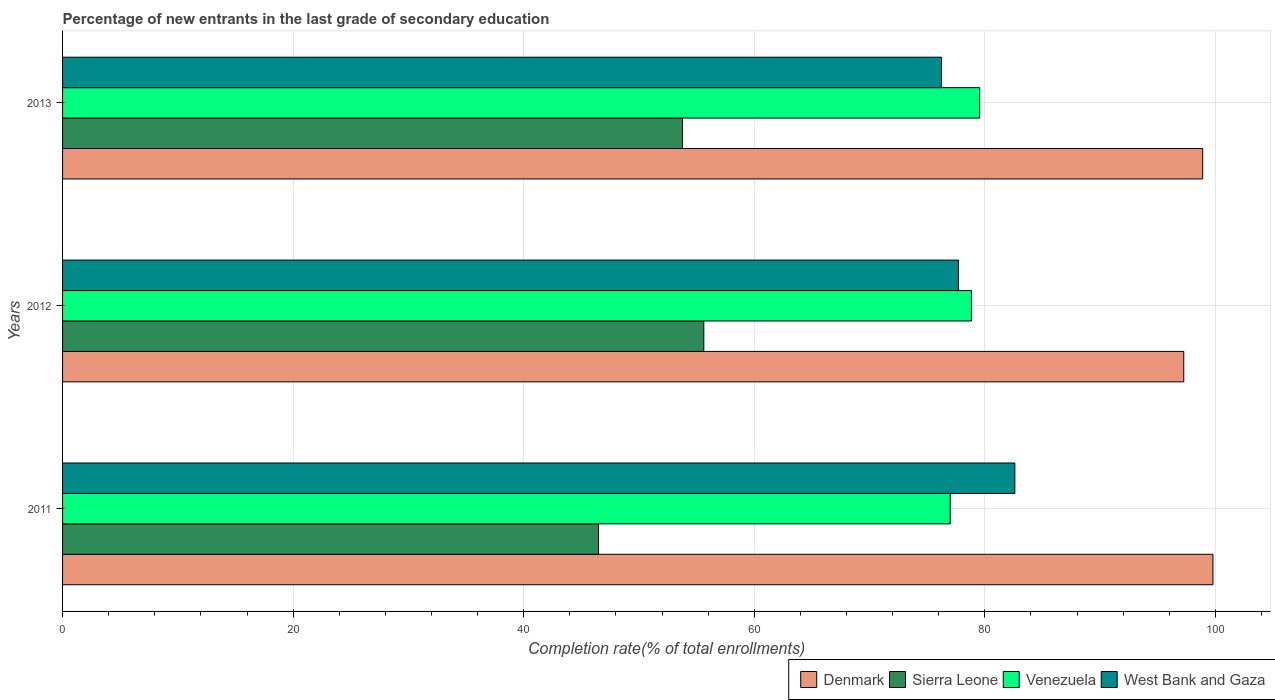How many bars are there on the 2nd tick from the top?
Give a very brief answer. 4. How many bars are there on the 3rd tick from the bottom?
Your answer should be compact. 4. What is the label of the 1st group of bars from the top?
Provide a succinct answer. 2013. What is the percentage of new entrants in Denmark in 2011?
Keep it short and to the point. 99.79. Across all years, what is the maximum percentage of new entrants in West Bank and Gaza?
Ensure brevity in your answer.  82.61. Across all years, what is the minimum percentage of new entrants in West Bank and Gaza?
Your answer should be very brief. 76.24. In which year was the percentage of new entrants in Venezuela maximum?
Give a very brief answer. 2013. What is the total percentage of new entrants in Denmark in the graph?
Your answer should be very brief. 295.95. What is the difference between the percentage of new entrants in Sierra Leone in 2011 and that in 2012?
Offer a terse response. -9.13. What is the difference between the percentage of new entrants in Sierra Leone in 2013 and the percentage of new entrants in Denmark in 2012?
Your response must be concise. -43.49. What is the average percentage of new entrants in Sierra Leone per year?
Provide a succinct answer. 51.96. In the year 2011, what is the difference between the percentage of new entrants in Denmark and percentage of new entrants in Sierra Leone?
Offer a terse response. 53.3. In how many years, is the percentage of new entrants in Denmark greater than 56 %?
Your answer should be very brief. 3. What is the ratio of the percentage of new entrants in Denmark in 2011 to that in 2012?
Offer a terse response. 1.03. Is the percentage of new entrants in West Bank and Gaza in 2011 less than that in 2012?
Make the answer very short. No. What is the difference between the highest and the second highest percentage of new entrants in West Bank and Gaza?
Provide a short and direct response. 4.9. What is the difference between the highest and the lowest percentage of new entrants in Denmark?
Ensure brevity in your answer.  2.53. In how many years, is the percentage of new entrants in Denmark greater than the average percentage of new entrants in Denmark taken over all years?
Your answer should be compact. 2. Is the sum of the percentage of new entrants in Venezuela in 2012 and 2013 greater than the maximum percentage of new entrants in West Bank and Gaza across all years?
Provide a short and direct response. Yes. Is it the case that in every year, the sum of the percentage of new entrants in Venezuela and percentage of new entrants in West Bank and Gaza is greater than the sum of percentage of new entrants in Denmark and percentage of new entrants in Sierra Leone?
Provide a succinct answer. Yes. Is it the case that in every year, the sum of the percentage of new entrants in Denmark and percentage of new entrants in West Bank and Gaza is greater than the percentage of new entrants in Sierra Leone?
Your answer should be compact. Yes. Are all the bars in the graph horizontal?
Ensure brevity in your answer.  Yes. Where does the legend appear in the graph?
Provide a succinct answer. Bottom right. How many legend labels are there?
Provide a short and direct response. 4. What is the title of the graph?
Keep it short and to the point. Percentage of new entrants in the last grade of secondary education. Does "Isle of Man" appear as one of the legend labels in the graph?
Provide a short and direct response. No. What is the label or title of the X-axis?
Your response must be concise. Completion rate(% of total enrollments). What is the Completion rate(% of total enrollments) of Denmark in 2011?
Your response must be concise. 99.79. What is the Completion rate(% of total enrollments) of Sierra Leone in 2011?
Provide a short and direct response. 46.49. What is the Completion rate(% of total enrollments) of Venezuela in 2011?
Provide a succinct answer. 77. What is the Completion rate(% of total enrollments) of West Bank and Gaza in 2011?
Your answer should be very brief. 82.61. What is the Completion rate(% of total enrollments) in Denmark in 2012?
Your answer should be compact. 97.26. What is the Completion rate(% of total enrollments) of Sierra Leone in 2012?
Your answer should be compact. 55.63. What is the Completion rate(% of total enrollments) in Venezuela in 2012?
Keep it short and to the point. 78.84. What is the Completion rate(% of total enrollments) of West Bank and Gaza in 2012?
Your answer should be compact. 77.71. What is the Completion rate(% of total enrollments) of Denmark in 2013?
Offer a terse response. 98.9. What is the Completion rate(% of total enrollments) in Sierra Leone in 2013?
Your answer should be compact. 53.77. What is the Completion rate(% of total enrollments) in Venezuela in 2013?
Your answer should be compact. 79.56. What is the Completion rate(% of total enrollments) of West Bank and Gaza in 2013?
Ensure brevity in your answer.  76.24. Across all years, what is the maximum Completion rate(% of total enrollments) in Denmark?
Keep it short and to the point. 99.79. Across all years, what is the maximum Completion rate(% of total enrollments) of Sierra Leone?
Make the answer very short. 55.63. Across all years, what is the maximum Completion rate(% of total enrollments) of Venezuela?
Your answer should be very brief. 79.56. Across all years, what is the maximum Completion rate(% of total enrollments) in West Bank and Gaza?
Provide a succinct answer. 82.61. Across all years, what is the minimum Completion rate(% of total enrollments) of Denmark?
Provide a succinct answer. 97.26. Across all years, what is the minimum Completion rate(% of total enrollments) in Sierra Leone?
Your answer should be very brief. 46.49. Across all years, what is the minimum Completion rate(% of total enrollments) of Venezuela?
Make the answer very short. 77. Across all years, what is the minimum Completion rate(% of total enrollments) in West Bank and Gaza?
Make the answer very short. 76.24. What is the total Completion rate(% of total enrollments) of Denmark in the graph?
Offer a very short reply. 295.95. What is the total Completion rate(% of total enrollments) in Sierra Leone in the graph?
Ensure brevity in your answer.  155.89. What is the total Completion rate(% of total enrollments) of Venezuela in the graph?
Your answer should be compact. 235.4. What is the total Completion rate(% of total enrollments) of West Bank and Gaza in the graph?
Provide a short and direct response. 236.56. What is the difference between the Completion rate(% of total enrollments) in Denmark in 2011 and that in 2012?
Keep it short and to the point. 2.53. What is the difference between the Completion rate(% of total enrollments) in Sierra Leone in 2011 and that in 2012?
Give a very brief answer. -9.13. What is the difference between the Completion rate(% of total enrollments) of Venezuela in 2011 and that in 2012?
Ensure brevity in your answer.  -1.84. What is the difference between the Completion rate(% of total enrollments) in West Bank and Gaza in 2011 and that in 2012?
Offer a very short reply. 4.9. What is the difference between the Completion rate(% of total enrollments) in Denmark in 2011 and that in 2013?
Provide a succinct answer. 0.89. What is the difference between the Completion rate(% of total enrollments) in Sierra Leone in 2011 and that in 2013?
Give a very brief answer. -7.28. What is the difference between the Completion rate(% of total enrollments) of Venezuela in 2011 and that in 2013?
Offer a very short reply. -2.56. What is the difference between the Completion rate(% of total enrollments) of West Bank and Gaza in 2011 and that in 2013?
Your answer should be very brief. 6.36. What is the difference between the Completion rate(% of total enrollments) in Denmark in 2012 and that in 2013?
Your answer should be compact. -1.64. What is the difference between the Completion rate(% of total enrollments) in Sierra Leone in 2012 and that in 2013?
Keep it short and to the point. 1.85. What is the difference between the Completion rate(% of total enrollments) in Venezuela in 2012 and that in 2013?
Your response must be concise. -0.72. What is the difference between the Completion rate(% of total enrollments) in West Bank and Gaza in 2012 and that in 2013?
Your answer should be very brief. 1.47. What is the difference between the Completion rate(% of total enrollments) in Denmark in 2011 and the Completion rate(% of total enrollments) in Sierra Leone in 2012?
Your answer should be compact. 44.17. What is the difference between the Completion rate(% of total enrollments) of Denmark in 2011 and the Completion rate(% of total enrollments) of Venezuela in 2012?
Your answer should be very brief. 20.95. What is the difference between the Completion rate(% of total enrollments) in Denmark in 2011 and the Completion rate(% of total enrollments) in West Bank and Gaza in 2012?
Offer a very short reply. 22.08. What is the difference between the Completion rate(% of total enrollments) of Sierra Leone in 2011 and the Completion rate(% of total enrollments) of Venezuela in 2012?
Offer a very short reply. -32.35. What is the difference between the Completion rate(% of total enrollments) in Sierra Leone in 2011 and the Completion rate(% of total enrollments) in West Bank and Gaza in 2012?
Offer a terse response. -31.22. What is the difference between the Completion rate(% of total enrollments) of Venezuela in 2011 and the Completion rate(% of total enrollments) of West Bank and Gaza in 2012?
Your answer should be compact. -0.71. What is the difference between the Completion rate(% of total enrollments) of Denmark in 2011 and the Completion rate(% of total enrollments) of Sierra Leone in 2013?
Offer a very short reply. 46.02. What is the difference between the Completion rate(% of total enrollments) of Denmark in 2011 and the Completion rate(% of total enrollments) of Venezuela in 2013?
Provide a succinct answer. 20.23. What is the difference between the Completion rate(% of total enrollments) of Denmark in 2011 and the Completion rate(% of total enrollments) of West Bank and Gaza in 2013?
Offer a very short reply. 23.55. What is the difference between the Completion rate(% of total enrollments) in Sierra Leone in 2011 and the Completion rate(% of total enrollments) in Venezuela in 2013?
Provide a short and direct response. -33.07. What is the difference between the Completion rate(% of total enrollments) in Sierra Leone in 2011 and the Completion rate(% of total enrollments) in West Bank and Gaza in 2013?
Offer a very short reply. -29.75. What is the difference between the Completion rate(% of total enrollments) of Venezuela in 2011 and the Completion rate(% of total enrollments) of West Bank and Gaza in 2013?
Keep it short and to the point. 0.76. What is the difference between the Completion rate(% of total enrollments) in Denmark in 2012 and the Completion rate(% of total enrollments) in Sierra Leone in 2013?
Your answer should be compact. 43.49. What is the difference between the Completion rate(% of total enrollments) of Denmark in 2012 and the Completion rate(% of total enrollments) of Venezuela in 2013?
Your answer should be compact. 17.7. What is the difference between the Completion rate(% of total enrollments) in Denmark in 2012 and the Completion rate(% of total enrollments) in West Bank and Gaza in 2013?
Provide a succinct answer. 21.02. What is the difference between the Completion rate(% of total enrollments) in Sierra Leone in 2012 and the Completion rate(% of total enrollments) in Venezuela in 2013?
Give a very brief answer. -23.93. What is the difference between the Completion rate(% of total enrollments) of Sierra Leone in 2012 and the Completion rate(% of total enrollments) of West Bank and Gaza in 2013?
Your response must be concise. -20.62. What is the difference between the Completion rate(% of total enrollments) of Venezuela in 2012 and the Completion rate(% of total enrollments) of West Bank and Gaza in 2013?
Offer a very short reply. 2.6. What is the average Completion rate(% of total enrollments) of Denmark per year?
Keep it short and to the point. 98.65. What is the average Completion rate(% of total enrollments) of Sierra Leone per year?
Your answer should be compact. 51.96. What is the average Completion rate(% of total enrollments) in Venezuela per year?
Give a very brief answer. 78.47. What is the average Completion rate(% of total enrollments) in West Bank and Gaza per year?
Give a very brief answer. 78.85. In the year 2011, what is the difference between the Completion rate(% of total enrollments) in Denmark and Completion rate(% of total enrollments) in Sierra Leone?
Your answer should be very brief. 53.3. In the year 2011, what is the difference between the Completion rate(% of total enrollments) of Denmark and Completion rate(% of total enrollments) of Venezuela?
Provide a succinct answer. 22.79. In the year 2011, what is the difference between the Completion rate(% of total enrollments) in Denmark and Completion rate(% of total enrollments) in West Bank and Gaza?
Ensure brevity in your answer.  17.19. In the year 2011, what is the difference between the Completion rate(% of total enrollments) in Sierra Leone and Completion rate(% of total enrollments) in Venezuela?
Make the answer very short. -30.51. In the year 2011, what is the difference between the Completion rate(% of total enrollments) of Sierra Leone and Completion rate(% of total enrollments) of West Bank and Gaza?
Keep it short and to the point. -36.11. In the year 2011, what is the difference between the Completion rate(% of total enrollments) in Venezuela and Completion rate(% of total enrollments) in West Bank and Gaza?
Provide a succinct answer. -5.61. In the year 2012, what is the difference between the Completion rate(% of total enrollments) in Denmark and Completion rate(% of total enrollments) in Sierra Leone?
Your response must be concise. 41.63. In the year 2012, what is the difference between the Completion rate(% of total enrollments) of Denmark and Completion rate(% of total enrollments) of Venezuela?
Ensure brevity in your answer.  18.42. In the year 2012, what is the difference between the Completion rate(% of total enrollments) in Denmark and Completion rate(% of total enrollments) in West Bank and Gaza?
Ensure brevity in your answer.  19.55. In the year 2012, what is the difference between the Completion rate(% of total enrollments) of Sierra Leone and Completion rate(% of total enrollments) of Venezuela?
Offer a very short reply. -23.21. In the year 2012, what is the difference between the Completion rate(% of total enrollments) in Sierra Leone and Completion rate(% of total enrollments) in West Bank and Gaza?
Your response must be concise. -22.08. In the year 2012, what is the difference between the Completion rate(% of total enrollments) in Venezuela and Completion rate(% of total enrollments) in West Bank and Gaza?
Ensure brevity in your answer.  1.13. In the year 2013, what is the difference between the Completion rate(% of total enrollments) in Denmark and Completion rate(% of total enrollments) in Sierra Leone?
Keep it short and to the point. 45.13. In the year 2013, what is the difference between the Completion rate(% of total enrollments) in Denmark and Completion rate(% of total enrollments) in Venezuela?
Offer a very short reply. 19.34. In the year 2013, what is the difference between the Completion rate(% of total enrollments) of Denmark and Completion rate(% of total enrollments) of West Bank and Gaza?
Keep it short and to the point. 22.66. In the year 2013, what is the difference between the Completion rate(% of total enrollments) in Sierra Leone and Completion rate(% of total enrollments) in Venezuela?
Provide a succinct answer. -25.79. In the year 2013, what is the difference between the Completion rate(% of total enrollments) in Sierra Leone and Completion rate(% of total enrollments) in West Bank and Gaza?
Offer a terse response. -22.47. In the year 2013, what is the difference between the Completion rate(% of total enrollments) in Venezuela and Completion rate(% of total enrollments) in West Bank and Gaza?
Your answer should be compact. 3.32. What is the ratio of the Completion rate(% of total enrollments) of Sierra Leone in 2011 to that in 2012?
Make the answer very short. 0.84. What is the ratio of the Completion rate(% of total enrollments) of Venezuela in 2011 to that in 2012?
Provide a short and direct response. 0.98. What is the ratio of the Completion rate(% of total enrollments) of West Bank and Gaza in 2011 to that in 2012?
Your response must be concise. 1.06. What is the ratio of the Completion rate(% of total enrollments) in Denmark in 2011 to that in 2013?
Offer a very short reply. 1.01. What is the ratio of the Completion rate(% of total enrollments) of Sierra Leone in 2011 to that in 2013?
Give a very brief answer. 0.86. What is the ratio of the Completion rate(% of total enrollments) of Venezuela in 2011 to that in 2013?
Offer a very short reply. 0.97. What is the ratio of the Completion rate(% of total enrollments) in West Bank and Gaza in 2011 to that in 2013?
Provide a short and direct response. 1.08. What is the ratio of the Completion rate(% of total enrollments) in Denmark in 2012 to that in 2013?
Make the answer very short. 0.98. What is the ratio of the Completion rate(% of total enrollments) in Sierra Leone in 2012 to that in 2013?
Your response must be concise. 1.03. What is the ratio of the Completion rate(% of total enrollments) of Venezuela in 2012 to that in 2013?
Offer a terse response. 0.99. What is the ratio of the Completion rate(% of total enrollments) in West Bank and Gaza in 2012 to that in 2013?
Give a very brief answer. 1.02. What is the difference between the highest and the second highest Completion rate(% of total enrollments) in Denmark?
Offer a terse response. 0.89. What is the difference between the highest and the second highest Completion rate(% of total enrollments) of Sierra Leone?
Offer a terse response. 1.85. What is the difference between the highest and the second highest Completion rate(% of total enrollments) in Venezuela?
Your answer should be very brief. 0.72. What is the difference between the highest and the second highest Completion rate(% of total enrollments) of West Bank and Gaza?
Your response must be concise. 4.9. What is the difference between the highest and the lowest Completion rate(% of total enrollments) of Denmark?
Your answer should be compact. 2.53. What is the difference between the highest and the lowest Completion rate(% of total enrollments) in Sierra Leone?
Your answer should be very brief. 9.13. What is the difference between the highest and the lowest Completion rate(% of total enrollments) in Venezuela?
Your answer should be compact. 2.56. What is the difference between the highest and the lowest Completion rate(% of total enrollments) of West Bank and Gaza?
Your response must be concise. 6.36. 